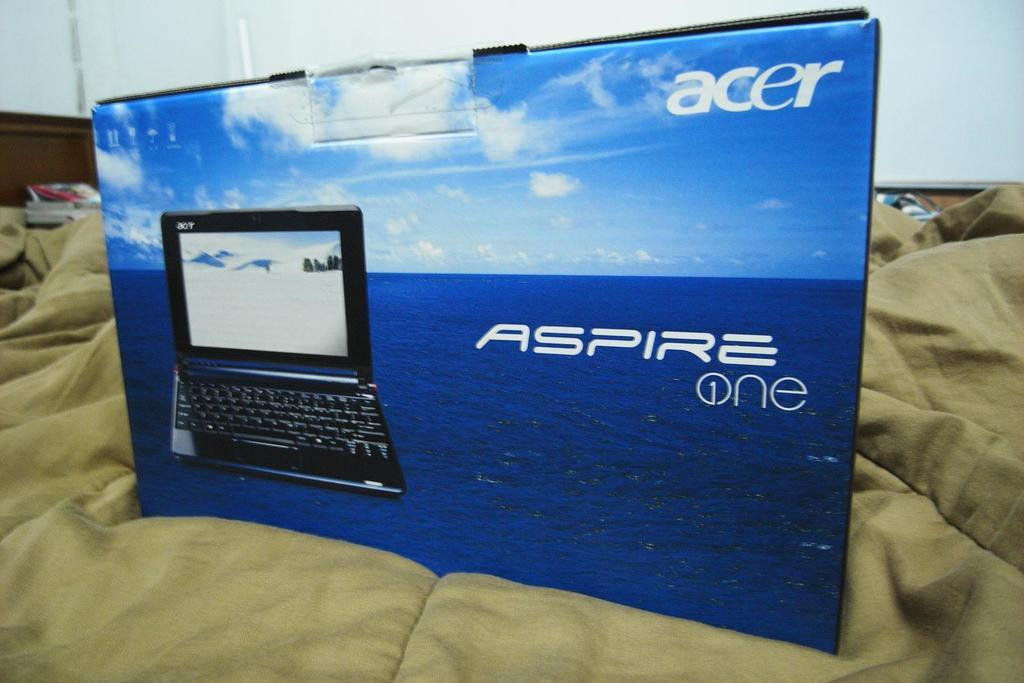Provide a one-sentence caption for the provided image. The packaging for an Acer branded laptop is on top of the bed. 